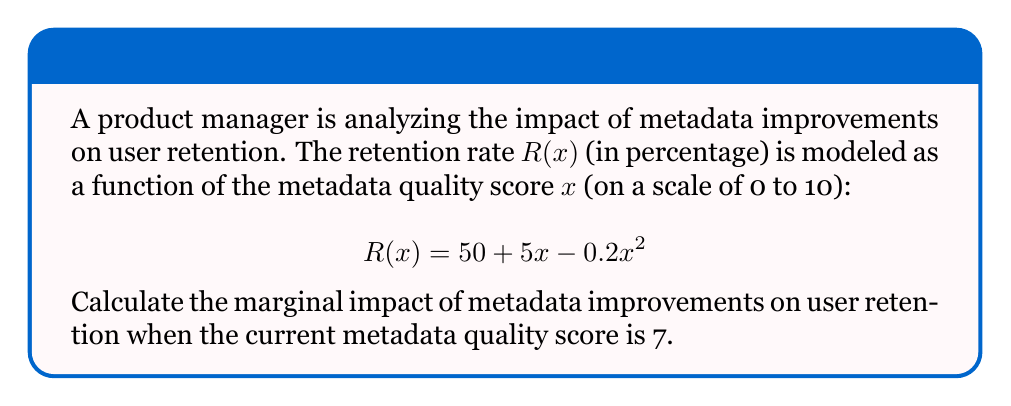Show me your answer to this math problem. To find the marginal impact of metadata improvements on user retention, we need to calculate the derivative of the retention rate function $R(x)$ and evaluate it at $x = 7$. This will give us the rate of change in retention with respect to metadata quality at that point.

Step 1: Find the derivative of $R(x)$.
$$\frac{d}{dx}R(x) = \frac{d}{dx}(50 + 5x - 0.2x^2)$$
$$R'(x) = 5 - 0.4x$$

Step 2: Evaluate the derivative at $x = 7$.
$$R'(7) = 5 - 0.4(7)$$
$$R'(7) = 5 - 2.8$$
$$R'(7) = 2.2$$

The marginal impact is 2.2 percentage points per unit increase in metadata quality score when the current score is 7.
Answer: $2.2$ percentage points per unit increase 